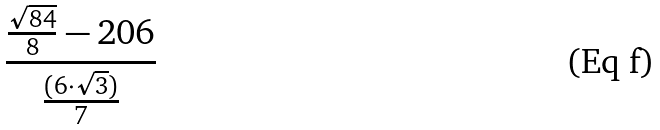Convert formula to latex. <formula><loc_0><loc_0><loc_500><loc_500>\frac { \frac { \sqrt { 8 4 } } { 8 } - 2 0 6 } { \frac { ( 6 \cdot \sqrt { 3 } ) } { 7 } }</formula> 